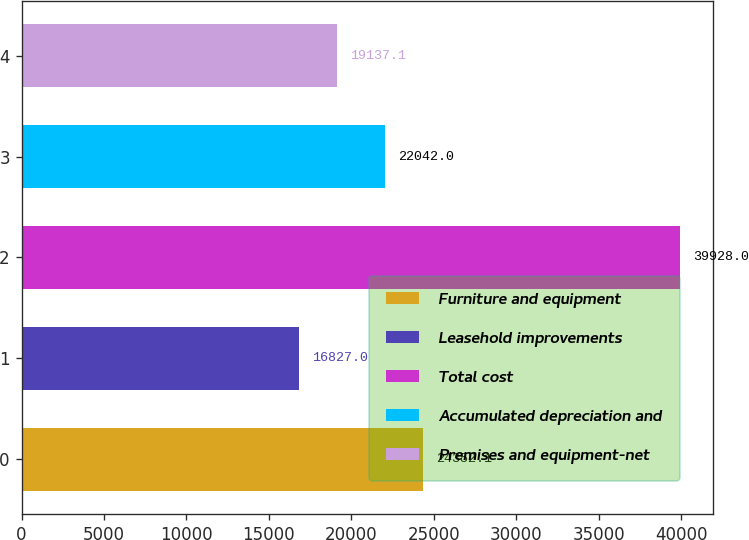<chart> <loc_0><loc_0><loc_500><loc_500><bar_chart><fcel>Furniture and equipment<fcel>Leasehold improvements<fcel>Total cost<fcel>Accumulated depreciation and<fcel>Premises and equipment-net<nl><fcel>24352.1<fcel>16827<fcel>39928<fcel>22042<fcel>19137.1<nl></chart> 